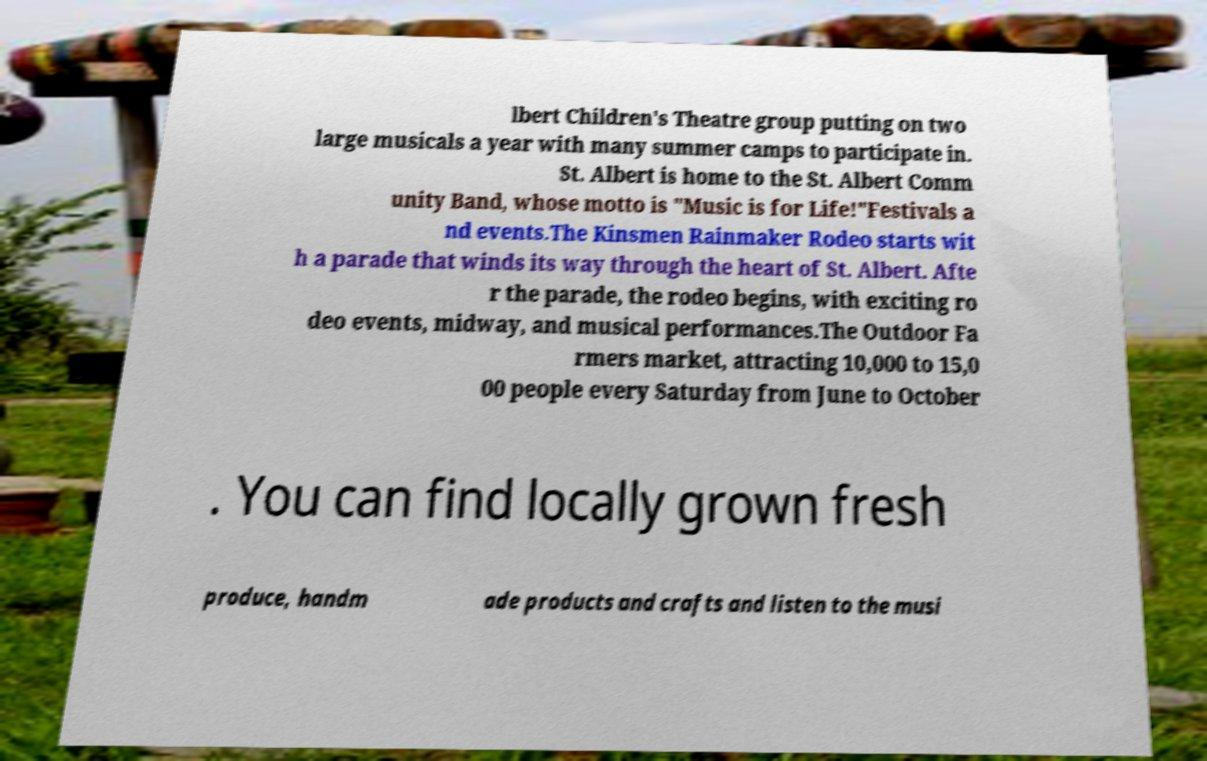I need the written content from this picture converted into text. Can you do that? lbert Children's Theatre group putting on two large musicals a year with many summer camps to participate in. St. Albert is home to the St. Albert Comm unity Band, whose motto is "Music is for Life!"Festivals a nd events.The Kinsmen Rainmaker Rodeo starts wit h a parade that winds its way through the heart of St. Albert. Afte r the parade, the rodeo begins, with exciting ro deo events, midway, and musical performances.The Outdoor Fa rmers market, attracting 10,000 to 15,0 00 people every Saturday from June to October . You can find locally grown fresh produce, handm ade products and crafts and listen to the musi 